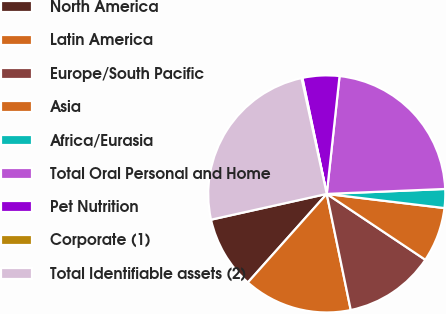<chart> <loc_0><loc_0><loc_500><loc_500><pie_chart><fcel>North America<fcel>Latin America<fcel>Europe/South Pacific<fcel>Asia<fcel>Africa/Eurasia<fcel>Total Oral Personal and Home<fcel>Pet Nutrition<fcel>Corporate (1)<fcel>Total Identifiable assets (2)<nl><fcel>9.93%<fcel>14.83%<fcel>12.38%<fcel>7.47%<fcel>2.57%<fcel>22.61%<fcel>5.02%<fcel>0.12%<fcel>25.07%<nl></chart> 